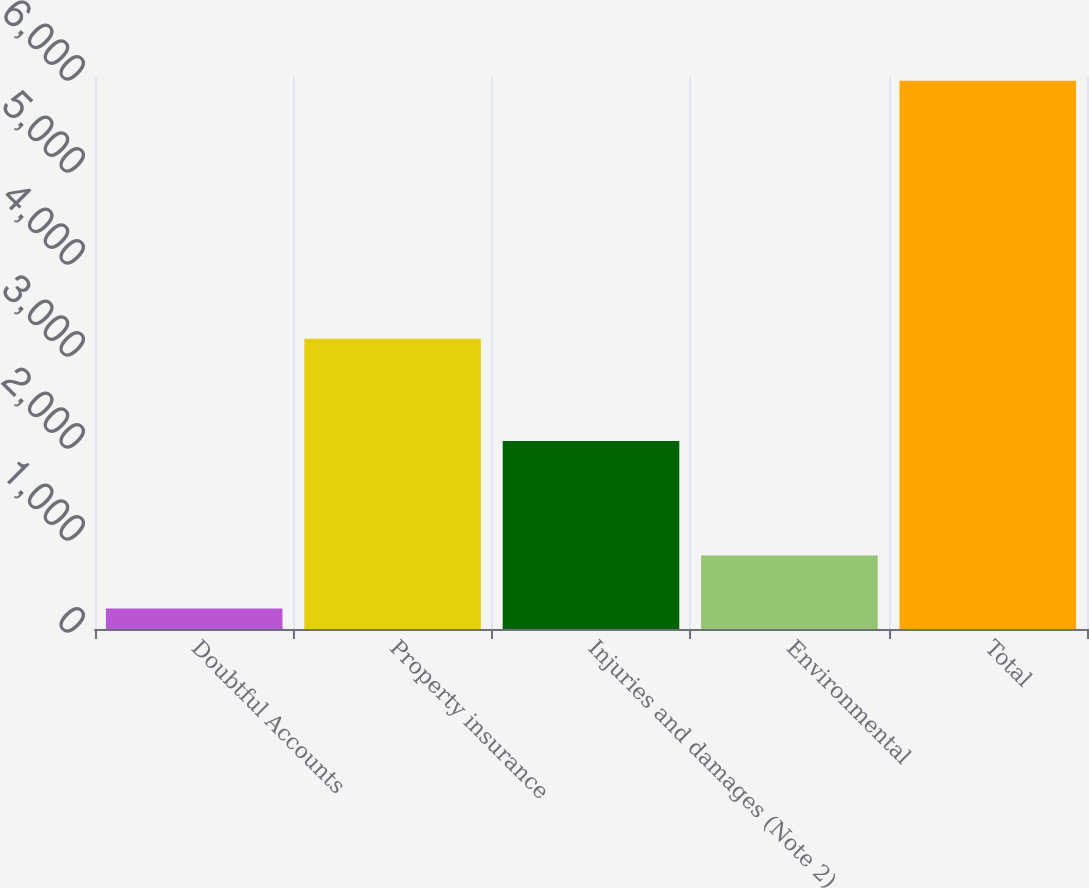Convert chart to OTSL. <chart><loc_0><loc_0><loc_500><loc_500><bar_chart><fcel>Doubtful Accounts<fcel>Property insurance<fcel>Injuries and damages (Note 2)<fcel>Environmental<fcel>Total<nl><fcel>224<fcel>3154<fcel>2043<fcel>797.6<fcel>5960<nl></chart> 